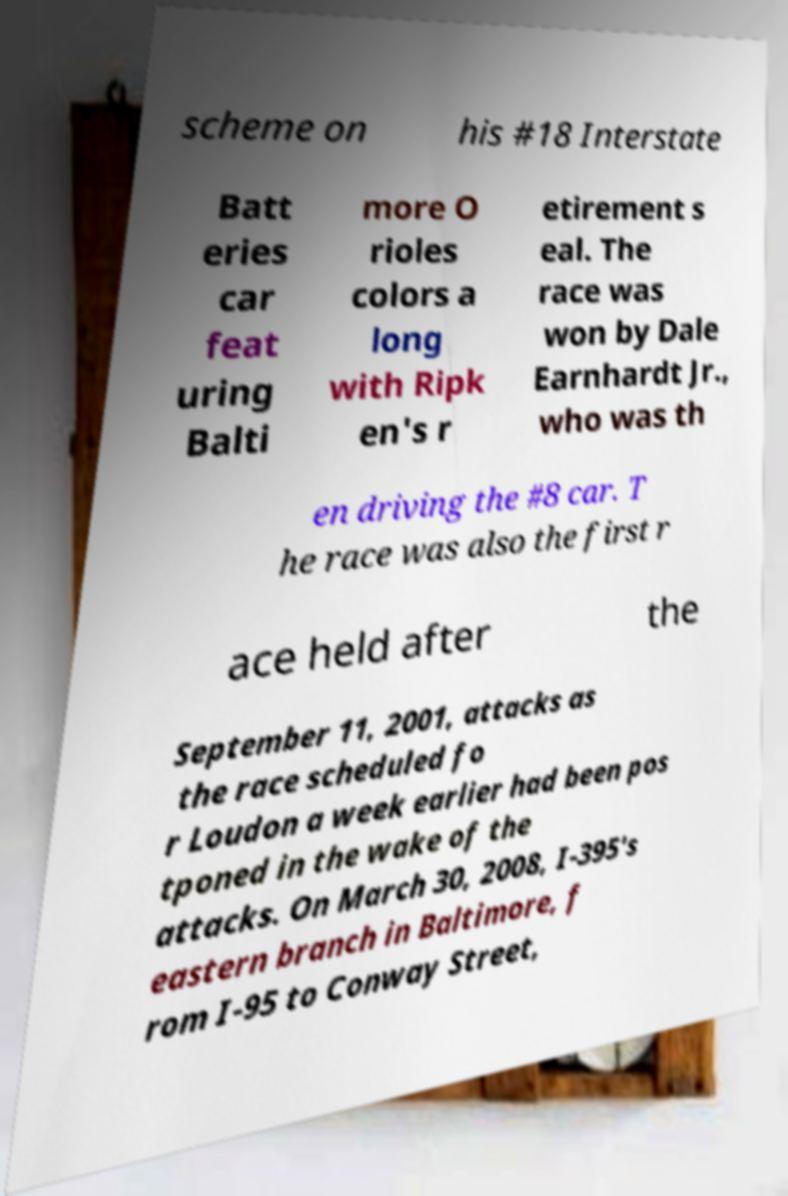Could you assist in decoding the text presented in this image and type it out clearly? scheme on his #18 Interstate Batt eries car feat uring Balti more O rioles colors a long with Ripk en's r etirement s eal. The race was won by Dale Earnhardt Jr., who was th en driving the #8 car. T he race was also the first r ace held after the September 11, 2001, attacks as the race scheduled fo r Loudon a week earlier had been pos tponed in the wake of the attacks. On March 30, 2008, I-395's eastern branch in Baltimore, f rom I-95 to Conway Street, 